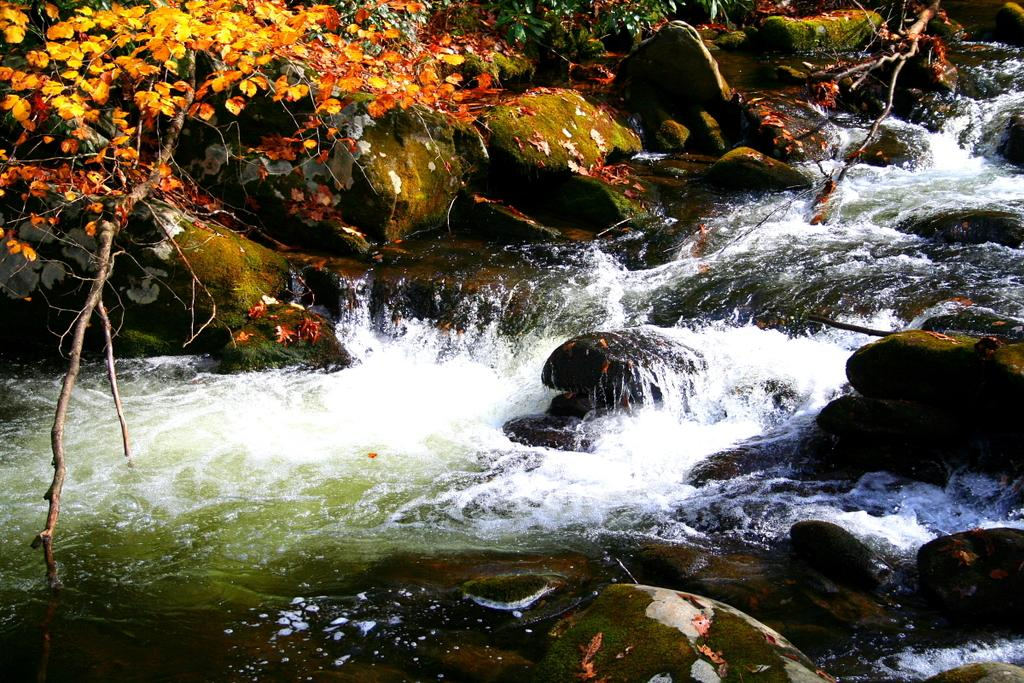What type of natural feature can be seen in the image? There is a river in the image. What objects can be found in or near the river? There are stones in the image. What type of plant material is present in the image? Leaves are present in the image. What part of a tree can be seen in the image? Tree branches are visible in the image. What type of pencil can be seen floating in the river in the image? There is no pencil present in the image, and therefore no such object can be observed. 